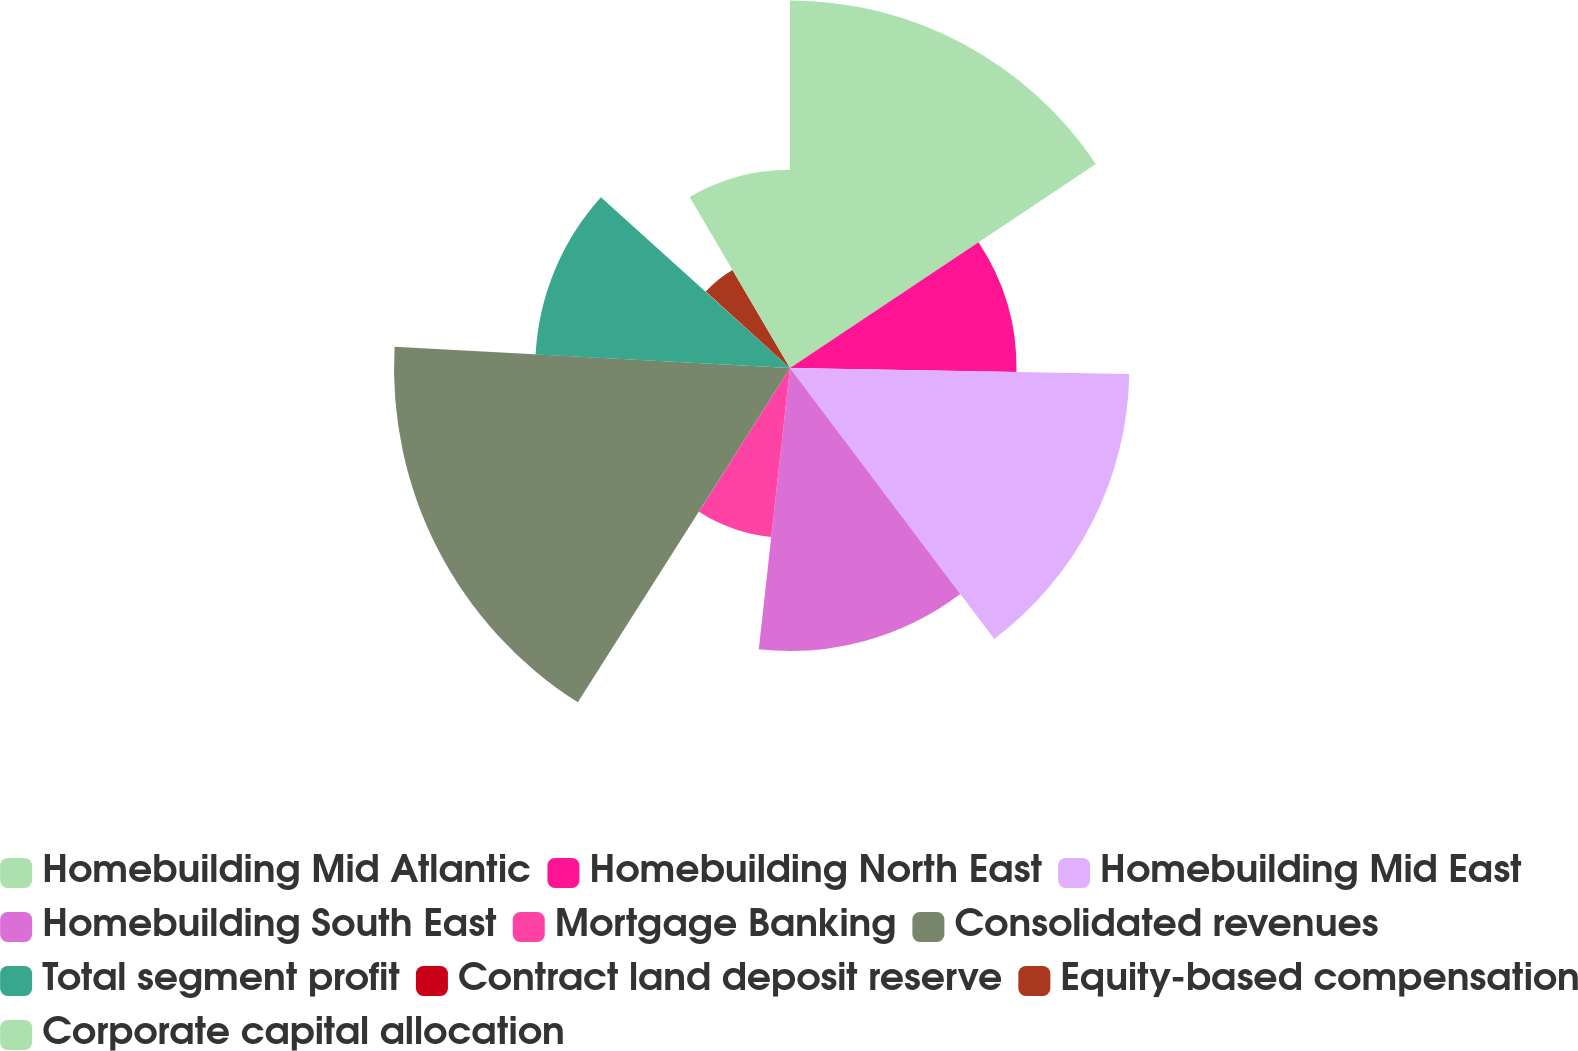<chart> <loc_0><loc_0><loc_500><loc_500><pie_chart><fcel>Homebuilding Mid Atlantic<fcel>Homebuilding North East<fcel>Homebuilding Mid East<fcel>Homebuilding South East<fcel>Mortgage Banking<fcel>Consolidated revenues<fcel>Total segment profit<fcel>Contract land deposit reserve<fcel>Equity-based compensation<fcel>Corporate capital allocation<nl><fcel>15.64%<fcel>9.64%<fcel>14.44%<fcel>12.04%<fcel>7.24%<fcel>16.85%<fcel>10.84%<fcel>0.03%<fcel>4.84%<fcel>8.44%<nl></chart> 